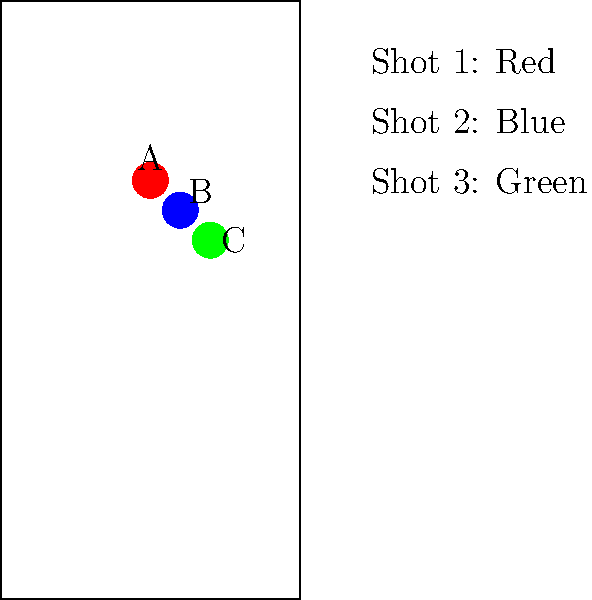Based on the body diagram showing three overlapping gunshot wounds (A, B, and C), determine the most likely sequence in which the shots were fired. To determine the sequence of gunshots using overlapping wound patterns, we need to analyze the relationship between the wounds:

1. Observe the position and overlap of the wounds:
   - Wound A (red) is partially covered by wound B (blue).
   - Wound B (blue) is partially covered by wound C (green).
   - Wound C (green) is not covered by any other wound.

2. Apply the principle that a later shot can overlap an earlier shot, but not vice versa:
   - Since A is partially covered by B, A must have occurred before B.
   - Since B is partially covered by C, B must have occurred before C.
   - C is not covered by any other wound, suggesting it was the last shot.

3. Construct the sequence based on these observations:
   - A occurred first
   - B occurred second
   - C occurred last

4. Double-check the sequence for consistency:
   - This sequence explains all observed overlaps without contradictions.

Therefore, the most likely sequence of the shots is A → B → C.
Answer: A → B → C 